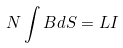Convert formula to latex. <formula><loc_0><loc_0><loc_500><loc_500>N \int B d S = L I</formula> 